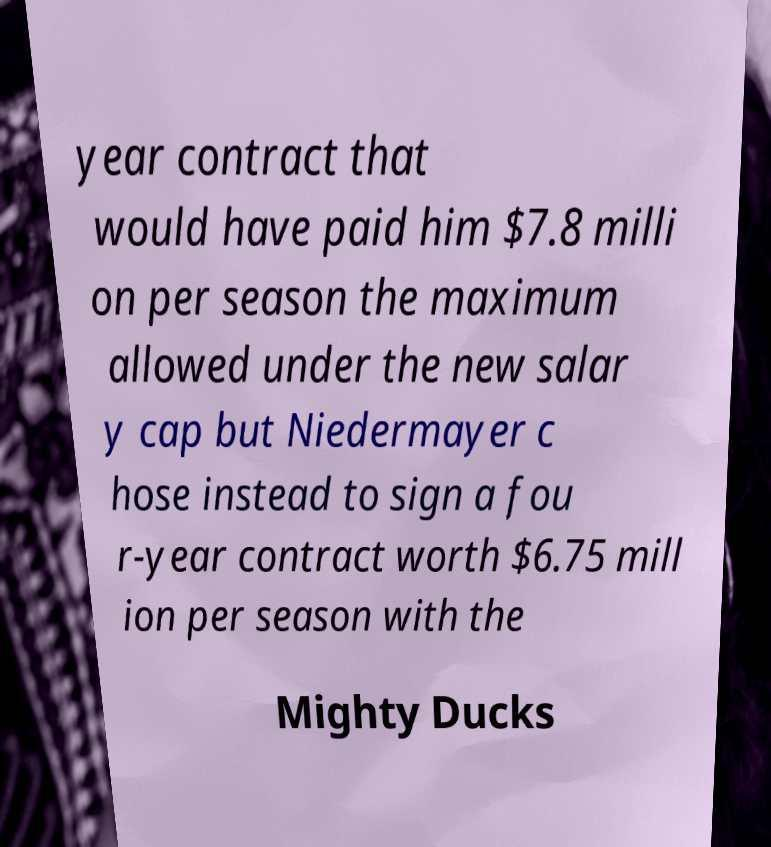Could you extract and type out the text from this image? year contract that would have paid him $7.8 milli on per season the maximum allowed under the new salar y cap but Niedermayer c hose instead to sign a fou r-year contract worth $6.75 mill ion per season with the Mighty Ducks 